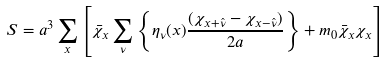Convert formula to latex. <formula><loc_0><loc_0><loc_500><loc_500>S = a ^ { 3 } \sum _ { x } \left [ \bar { \chi } _ { x } \sum _ { \nu } \left \{ \eta _ { \nu } ( x ) \frac { ( \chi _ { x + \hat { \nu } } - \chi _ { x - \hat { \nu } } ) } { 2 a } \right \} + m _ { 0 } \bar { \chi } _ { x } \chi _ { x } \right ]</formula> 